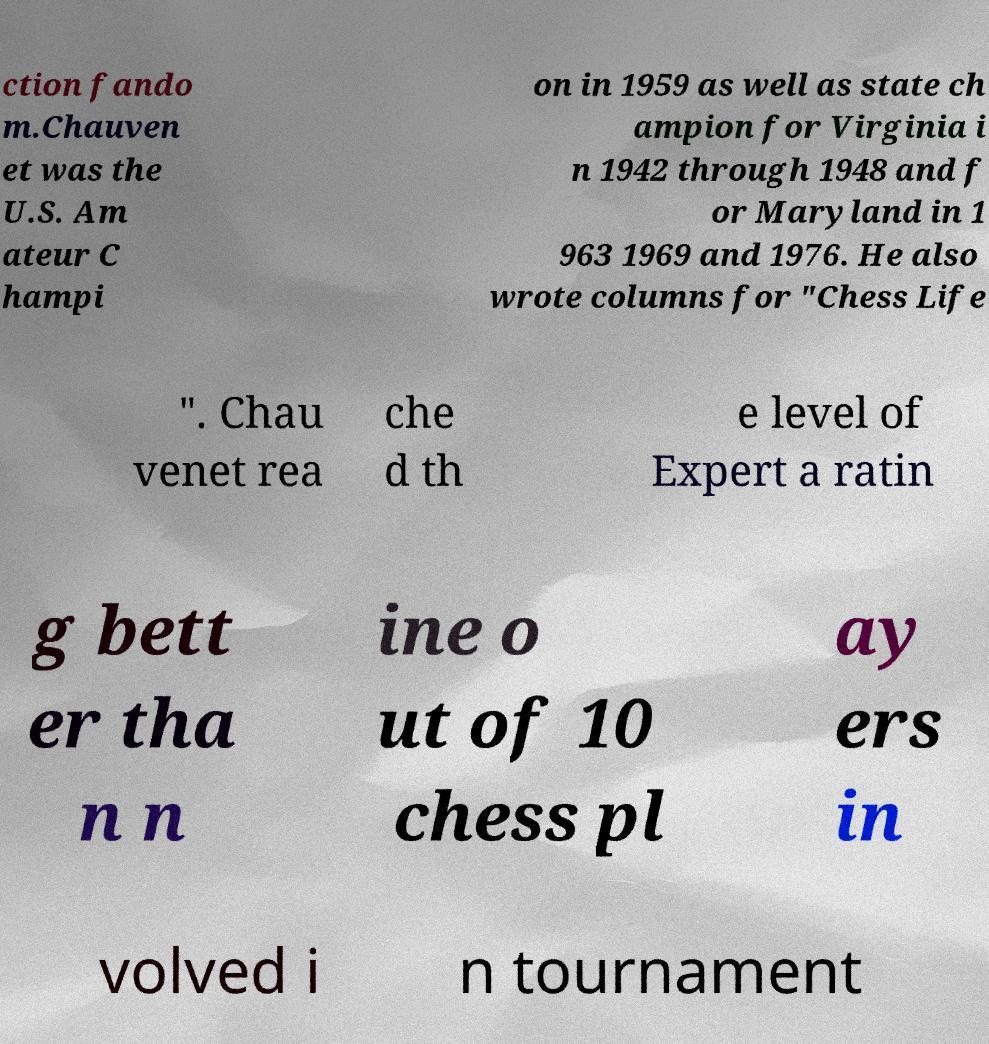Can you accurately transcribe the text from the provided image for me? ction fando m.Chauven et was the U.S. Am ateur C hampi on in 1959 as well as state ch ampion for Virginia i n 1942 through 1948 and f or Maryland in 1 963 1969 and 1976. He also wrote columns for "Chess Life ". Chau venet rea che d th e level of Expert a ratin g bett er tha n n ine o ut of 10 chess pl ay ers in volved i n tournament 